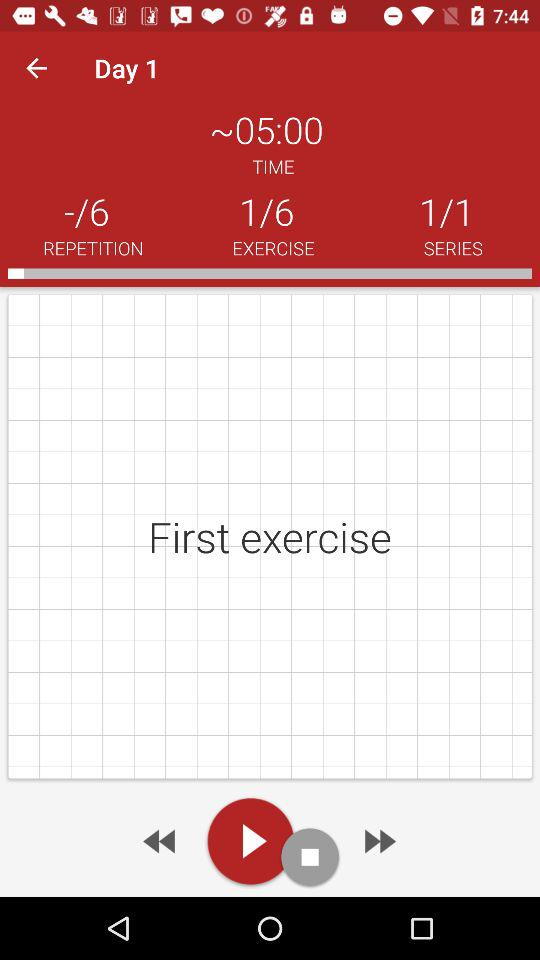At which series am I? You are at the first series. 